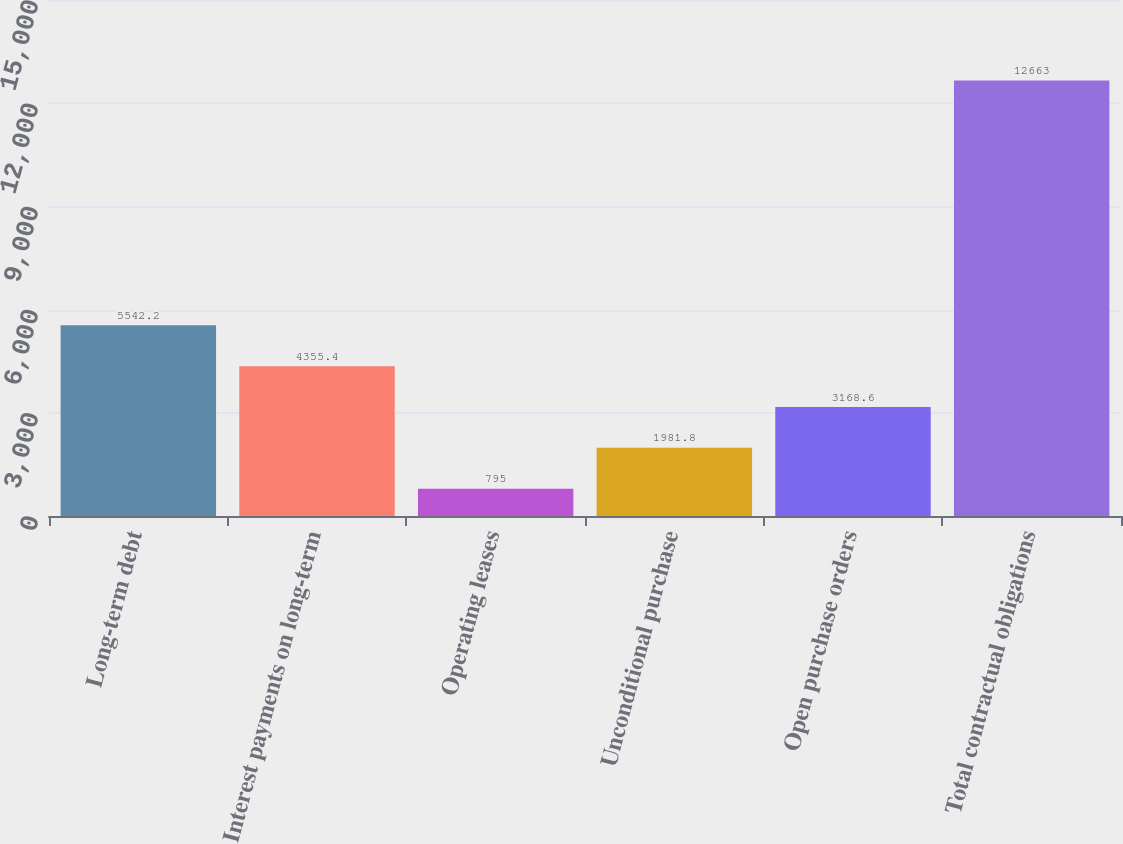Convert chart to OTSL. <chart><loc_0><loc_0><loc_500><loc_500><bar_chart><fcel>Long-term debt<fcel>Interest payments on long-term<fcel>Operating leases<fcel>Unconditional purchase<fcel>Open purchase orders<fcel>Total contractual obligations<nl><fcel>5542.2<fcel>4355.4<fcel>795<fcel>1981.8<fcel>3168.6<fcel>12663<nl></chart> 